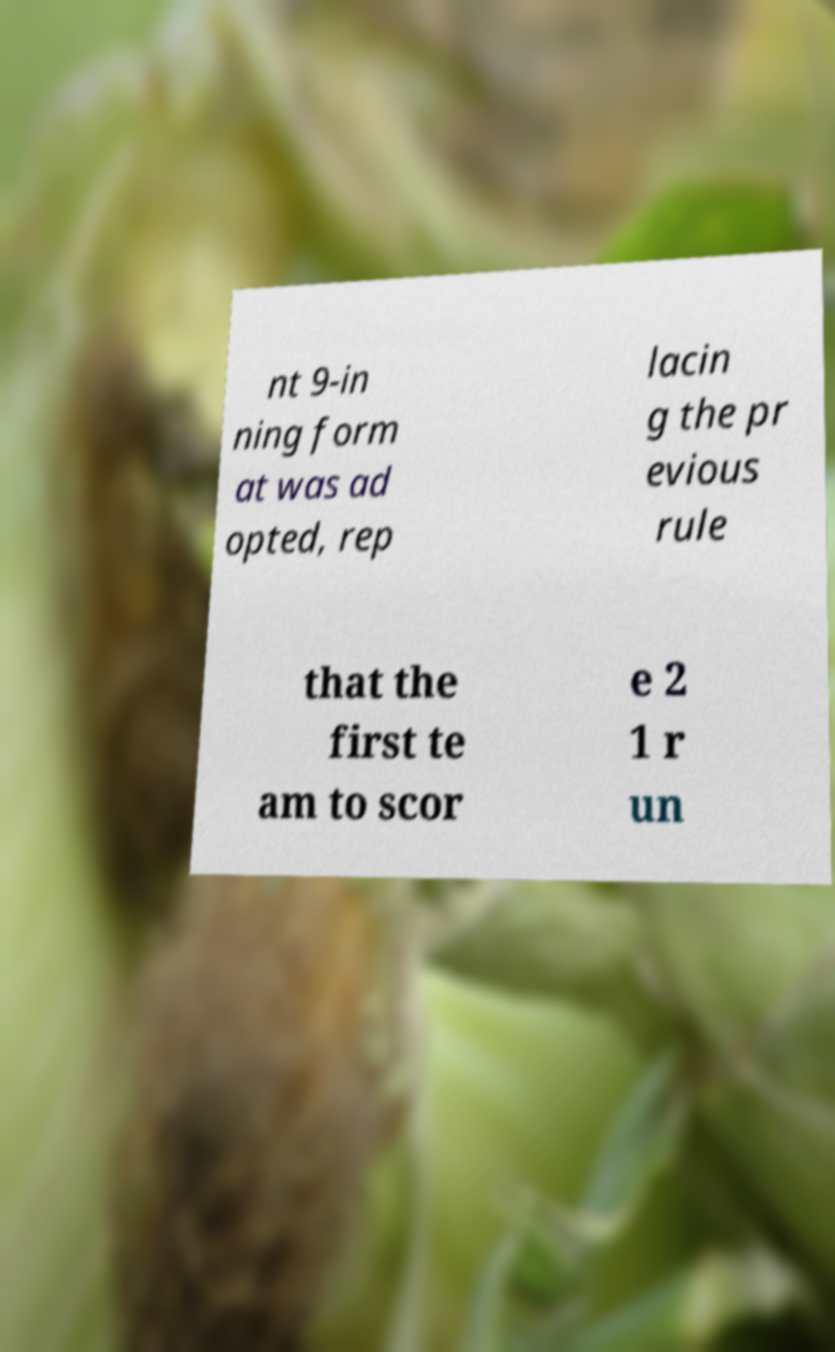Could you assist in decoding the text presented in this image and type it out clearly? nt 9-in ning form at was ad opted, rep lacin g the pr evious rule that the first te am to scor e 2 1 r un 